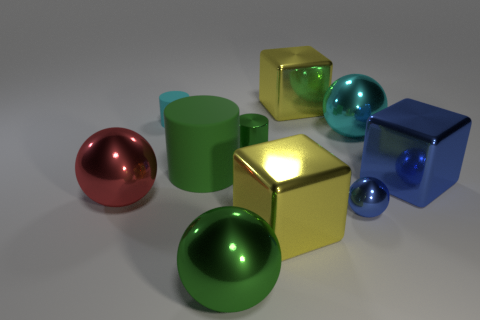What number of things are yellow things that are behind the small green cylinder or small green things?
Your answer should be very brief. 2. What number of things are small blue metal things or spheres right of the big cylinder?
Keep it short and to the point. 3. There is a green thing that is on the right side of the green object in front of the big red sphere; what number of yellow blocks are left of it?
Provide a succinct answer. 0. There is a cylinder that is the same size as the blue cube; what is it made of?
Offer a very short reply. Rubber. Is there a green rubber block of the same size as the cyan metal ball?
Your answer should be compact. No. What is the color of the big matte thing?
Provide a short and direct response. Green. What is the color of the small metal object behind the green cylinder to the left of the big green metallic thing?
Keep it short and to the point. Green. What is the shape of the cyan thing on the left side of the cylinder on the right side of the green thing that is in front of the large rubber cylinder?
Provide a succinct answer. Cylinder. How many small cyan objects have the same material as the large cylinder?
Offer a terse response. 1. There is a tiny metal thing behind the big blue shiny cube; how many metallic things are in front of it?
Keep it short and to the point. 5. 